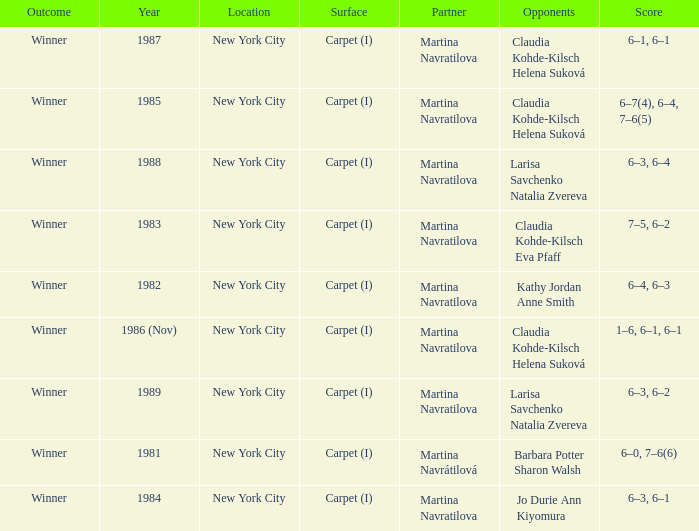Who were all of the opponents in 1984? Jo Durie Ann Kiyomura. 